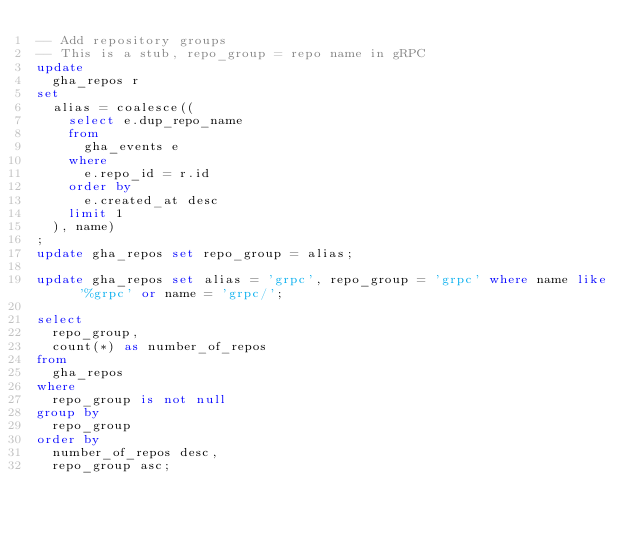<code> <loc_0><loc_0><loc_500><loc_500><_SQL_>-- Add repository groups
-- This is a stub, repo_group = repo name in gRPC
update
  gha_repos r
set
  alias = coalesce((
    select e.dup_repo_name
    from
      gha_events e
    where
      e.repo_id = r.id
    order by
      e.created_at desc
    limit 1
  ), name)
;
update gha_repos set repo_group = alias;

update gha_repos set alias = 'grpc', repo_group = 'grpc' where name like '%grpc' or name = 'grpc/';

select
  repo_group,
  count(*) as number_of_repos
from
  gha_repos
where
  repo_group is not null
group by
  repo_group
order by
  number_of_repos desc,
  repo_group asc;
</code> 